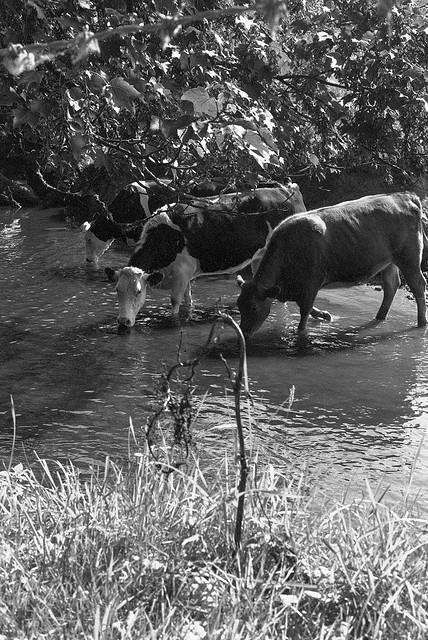Where are the cows standing?
Quick response, please. In water. How many cows?
Answer briefly. 3. What is this animal?
Quick response, please. Cow. Is this a popular gossiping area for cows?
Concise answer only. Yes. Do the cows look healthy?
Keep it brief. Yes. 